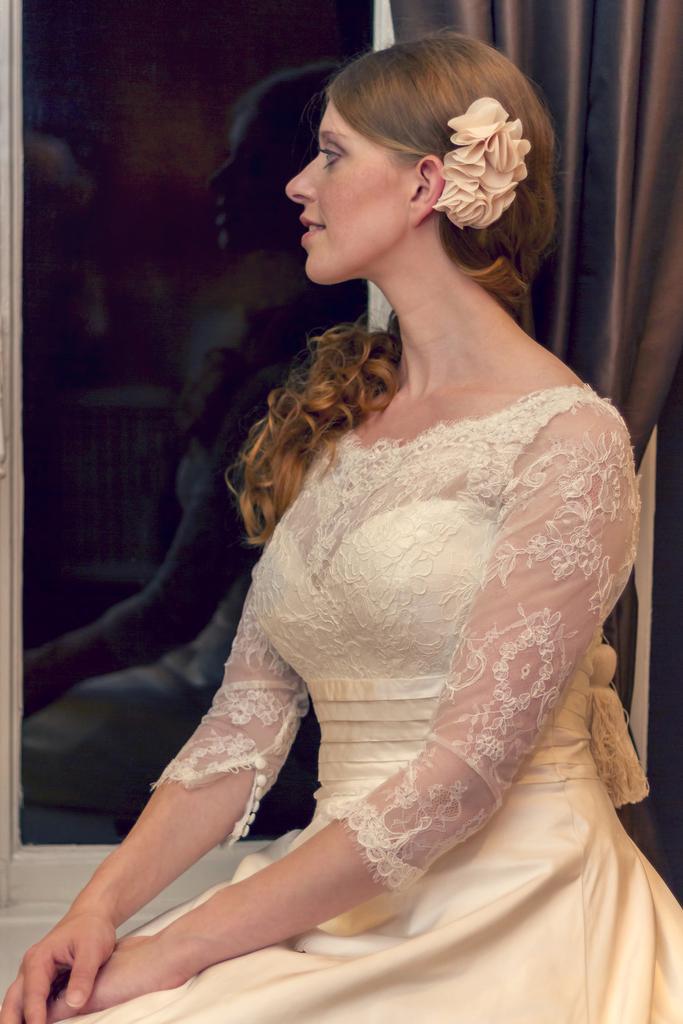How would you summarize this image in a sentence or two? In this image I can see the person is wearing cream color dress. I can see the glass window and the brow color curtain. 